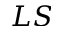<formula> <loc_0><loc_0><loc_500><loc_500>L S</formula> 